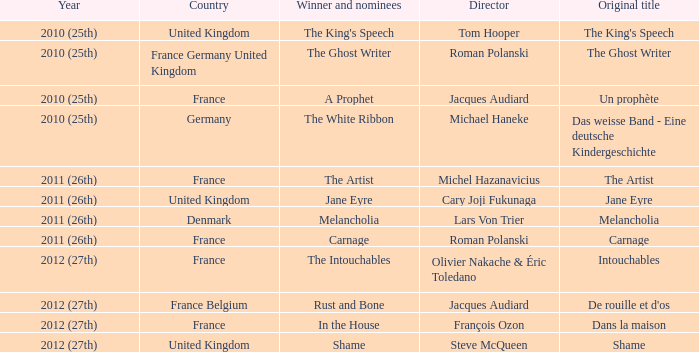Who was the director of the king's speech? Tom Hooper. 